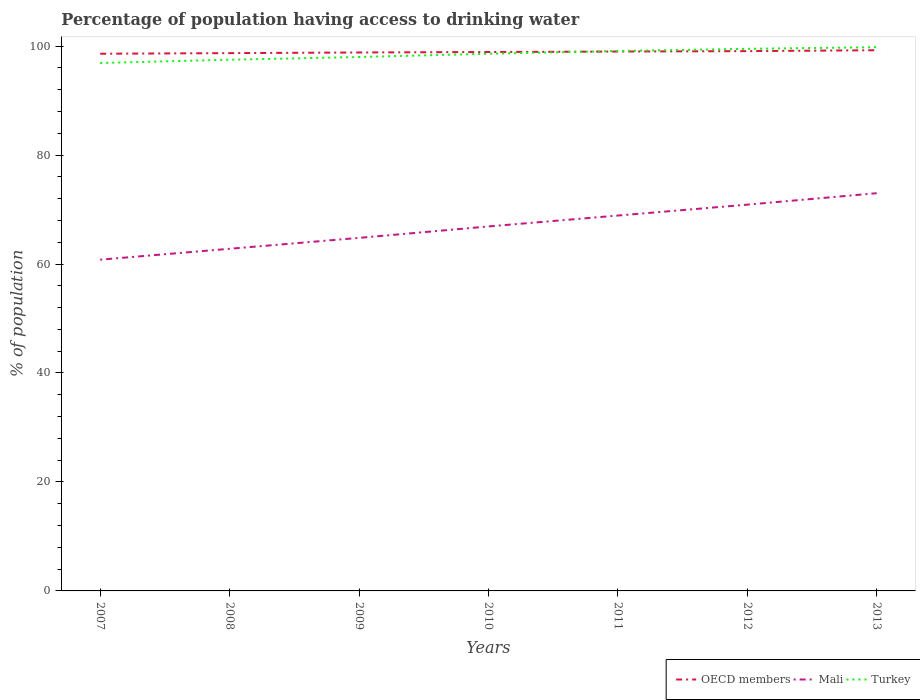How many different coloured lines are there?
Provide a succinct answer. 3. Does the line corresponding to OECD members intersect with the line corresponding to Turkey?
Give a very brief answer. Yes. Is the number of lines equal to the number of legend labels?
Your response must be concise. Yes. Across all years, what is the maximum percentage of population having access to drinking water in OECD members?
Ensure brevity in your answer.  98.6. In which year was the percentage of population having access to drinking water in OECD members maximum?
Ensure brevity in your answer.  2007. What is the total percentage of population having access to drinking water in Turkey in the graph?
Your answer should be very brief. -0.3. What is the difference between the highest and the second highest percentage of population having access to drinking water in Turkey?
Your answer should be very brief. 2.9. What is the difference between the highest and the lowest percentage of population having access to drinking water in Turkey?
Provide a succinct answer. 4. Is the percentage of population having access to drinking water in Turkey strictly greater than the percentage of population having access to drinking water in OECD members over the years?
Keep it short and to the point. No. How many lines are there?
Ensure brevity in your answer.  3. What is the difference between two consecutive major ticks on the Y-axis?
Your answer should be very brief. 20. Where does the legend appear in the graph?
Keep it short and to the point. Bottom right. What is the title of the graph?
Ensure brevity in your answer.  Percentage of population having access to drinking water. Does "Dominica" appear as one of the legend labels in the graph?
Offer a terse response. No. What is the label or title of the X-axis?
Provide a succinct answer. Years. What is the label or title of the Y-axis?
Offer a very short reply. % of population. What is the % of population of OECD members in 2007?
Make the answer very short. 98.6. What is the % of population of Mali in 2007?
Keep it short and to the point. 60.8. What is the % of population in Turkey in 2007?
Your response must be concise. 96.9. What is the % of population in OECD members in 2008?
Provide a succinct answer. 98.71. What is the % of population in Mali in 2008?
Keep it short and to the point. 62.8. What is the % of population in Turkey in 2008?
Ensure brevity in your answer.  97.5. What is the % of population of OECD members in 2009?
Provide a succinct answer. 98.83. What is the % of population of Mali in 2009?
Keep it short and to the point. 64.8. What is the % of population in OECD members in 2010?
Your answer should be compact. 98.92. What is the % of population of Mali in 2010?
Provide a short and direct response. 66.9. What is the % of population in Turkey in 2010?
Your answer should be compact. 98.6. What is the % of population of OECD members in 2011?
Provide a succinct answer. 99. What is the % of population in Mali in 2011?
Ensure brevity in your answer.  68.9. What is the % of population of Turkey in 2011?
Offer a very short reply. 99.1. What is the % of population in OECD members in 2012?
Give a very brief answer. 99.08. What is the % of population in Mali in 2012?
Provide a short and direct response. 70.9. What is the % of population of Turkey in 2012?
Give a very brief answer. 99.5. What is the % of population in OECD members in 2013?
Offer a very short reply. 99.24. What is the % of population in Turkey in 2013?
Your response must be concise. 99.8. Across all years, what is the maximum % of population in OECD members?
Ensure brevity in your answer.  99.24. Across all years, what is the maximum % of population of Mali?
Offer a very short reply. 73. Across all years, what is the maximum % of population of Turkey?
Keep it short and to the point. 99.8. Across all years, what is the minimum % of population of OECD members?
Your answer should be very brief. 98.6. Across all years, what is the minimum % of population of Mali?
Keep it short and to the point. 60.8. Across all years, what is the minimum % of population in Turkey?
Your response must be concise. 96.9. What is the total % of population in OECD members in the graph?
Give a very brief answer. 692.38. What is the total % of population of Mali in the graph?
Your response must be concise. 468.1. What is the total % of population in Turkey in the graph?
Offer a very short reply. 689.4. What is the difference between the % of population of OECD members in 2007 and that in 2008?
Your answer should be very brief. -0.11. What is the difference between the % of population of Mali in 2007 and that in 2008?
Give a very brief answer. -2. What is the difference between the % of population in Turkey in 2007 and that in 2008?
Your response must be concise. -0.6. What is the difference between the % of population in OECD members in 2007 and that in 2009?
Ensure brevity in your answer.  -0.23. What is the difference between the % of population in OECD members in 2007 and that in 2010?
Offer a terse response. -0.32. What is the difference between the % of population in Mali in 2007 and that in 2010?
Your answer should be very brief. -6.1. What is the difference between the % of population in OECD members in 2007 and that in 2011?
Offer a terse response. -0.4. What is the difference between the % of population of Mali in 2007 and that in 2011?
Offer a very short reply. -8.1. What is the difference between the % of population in OECD members in 2007 and that in 2012?
Keep it short and to the point. -0.48. What is the difference between the % of population in Mali in 2007 and that in 2012?
Offer a terse response. -10.1. What is the difference between the % of population of OECD members in 2007 and that in 2013?
Keep it short and to the point. -0.64. What is the difference between the % of population in Mali in 2007 and that in 2013?
Ensure brevity in your answer.  -12.2. What is the difference between the % of population of OECD members in 2008 and that in 2009?
Your response must be concise. -0.12. What is the difference between the % of population of Mali in 2008 and that in 2009?
Give a very brief answer. -2. What is the difference between the % of population in OECD members in 2008 and that in 2010?
Make the answer very short. -0.21. What is the difference between the % of population of Mali in 2008 and that in 2010?
Your response must be concise. -4.1. What is the difference between the % of population of Turkey in 2008 and that in 2010?
Your response must be concise. -1.1. What is the difference between the % of population in OECD members in 2008 and that in 2011?
Your answer should be very brief. -0.29. What is the difference between the % of population of Mali in 2008 and that in 2011?
Ensure brevity in your answer.  -6.1. What is the difference between the % of population in Turkey in 2008 and that in 2011?
Your answer should be very brief. -1.6. What is the difference between the % of population of OECD members in 2008 and that in 2012?
Provide a succinct answer. -0.37. What is the difference between the % of population in OECD members in 2008 and that in 2013?
Keep it short and to the point. -0.53. What is the difference between the % of population of Turkey in 2008 and that in 2013?
Your response must be concise. -2.3. What is the difference between the % of population of OECD members in 2009 and that in 2010?
Offer a terse response. -0.09. What is the difference between the % of population in Turkey in 2009 and that in 2010?
Your answer should be very brief. -0.6. What is the difference between the % of population in OECD members in 2009 and that in 2011?
Your answer should be compact. -0.17. What is the difference between the % of population of Mali in 2009 and that in 2011?
Your answer should be very brief. -4.1. What is the difference between the % of population of OECD members in 2009 and that in 2012?
Keep it short and to the point. -0.25. What is the difference between the % of population of Mali in 2009 and that in 2012?
Offer a very short reply. -6.1. What is the difference between the % of population in Turkey in 2009 and that in 2012?
Offer a terse response. -1.5. What is the difference between the % of population of OECD members in 2009 and that in 2013?
Provide a succinct answer. -0.41. What is the difference between the % of population of Turkey in 2009 and that in 2013?
Provide a short and direct response. -1.8. What is the difference between the % of population in OECD members in 2010 and that in 2011?
Offer a terse response. -0.08. What is the difference between the % of population of Mali in 2010 and that in 2011?
Ensure brevity in your answer.  -2. What is the difference between the % of population in OECD members in 2010 and that in 2012?
Offer a terse response. -0.16. What is the difference between the % of population of Mali in 2010 and that in 2012?
Provide a short and direct response. -4. What is the difference between the % of population in Turkey in 2010 and that in 2012?
Your answer should be very brief. -0.9. What is the difference between the % of population of OECD members in 2010 and that in 2013?
Make the answer very short. -0.33. What is the difference between the % of population in Mali in 2010 and that in 2013?
Keep it short and to the point. -6.1. What is the difference between the % of population of OECD members in 2011 and that in 2012?
Keep it short and to the point. -0.08. What is the difference between the % of population in Turkey in 2011 and that in 2012?
Offer a very short reply. -0.4. What is the difference between the % of population of OECD members in 2011 and that in 2013?
Your answer should be compact. -0.24. What is the difference between the % of population in OECD members in 2012 and that in 2013?
Ensure brevity in your answer.  -0.17. What is the difference between the % of population of Mali in 2012 and that in 2013?
Your answer should be compact. -2.1. What is the difference between the % of population of OECD members in 2007 and the % of population of Mali in 2008?
Your response must be concise. 35.8. What is the difference between the % of population in OECD members in 2007 and the % of population in Turkey in 2008?
Keep it short and to the point. 1.1. What is the difference between the % of population in Mali in 2007 and the % of population in Turkey in 2008?
Ensure brevity in your answer.  -36.7. What is the difference between the % of population of OECD members in 2007 and the % of population of Mali in 2009?
Your answer should be very brief. 33.8. What is the difference between the % of population in OECD members in 2007 and the % of population in Turkey in 2009?
Offer a terse response. 0.6. What is the difference between the % of population of Mali in 2007 and the % of population of Turkey in 2009?
Your response must be concise. -37.2. What is the difference between the % of population in OECD members in 2007 and the % of population in Mali in 2010?
Your response must be concise. 31.7. What is the difference between the % of population in OECD members in 2007 and the % of population in Turkey in 2010?
Give a very brief answer. 0. What is the difference between the % of population of Mali in 2007 and the % of population of Turkey in 2010?
Provide a succinct answer. -37.8. What is the difference between the % of population of OECD members in 2007 and the % of population of Mali in 2011?
Offer a terse response. 29.7. What is the difference between the % of population in OECD members in 2007 and the % of population in Turkey in 2011?
Ensure brevity in your answer.  -0.5. What is the difference between the % of population in Mali in 2007 and the % of population in Turkey in 2011?
Ensure brevity in your answer.  -38.3. What is the difference between the % of population in OECD members in 2007 and the % of population in Mali in 2012?
Give a very brief answer. 27.7. What is the difference between the % of population in OECD members in 2007 and the % of population in Turkey in 2012?
Keep it short and to the point. -0.9. What is the difference between the % of population in Mali in 2007 and the % of population in Turkey in 2012?
Keep it short and to the point. -38.7. What is the difference between the % of population of OECD members in 2007 and the % of population of Mali in 2013?
Offer a very short reply. 25.6. What is the difference between the % of population of OECD members in 2007 and the % of population of Turkey in 2013?
Make the answer very short. -1.2. What is the difference between the % of population in Mali in 2007 and the % of population in Turkey in 2013?
Ensure brevity in your answer.  -39. What is the difference between the % of population in OECD members in 2008 and the % of population in Mali in 2009?
Your answer should be very brief. 33.91. What is the difference between the % of population of OECD members in 2008 and the % of population of Turkey in 2009?
Provide a short and direct response. 0.71. What is the difference between the % of population of Mali in 2008 and the % of population of Turkey in 2009?
Offer a terse response. -35.2. What is the difference between the % of population of OECD members in 2008 and the % of population of Mali in 2010?
Ensure brevity in your answer.  31.81. What is the difference between the % of population of OECD members in 2008 and the % of population of Turkey in 2010?
Offer a very short reply. 0.11. What is the difference between the % of population in Mali in 2008 and the % of population in Turkey in 2010?
Offer a terse response. -35.8. What is the difference between the % of population of OECD members in 2008 and the % of population of Mali in 2011?
Provide a succinct answer. 29.81. What is the difference between the % of population of OECD members in 2008 and the % of population of Turkey in 2011?
Give a very brief answer. -0.39. What is the difference between the % of population of Mali in 2008 and the % of population of Turkey in 2011?
Provide a short and direct response. -36.3. What is the difference between the % of population of OECD members in 2008 and the % of population of Mali in 2012?
Ensure brevity in your answer.  27.81. What is the difference between the % of population in OECD members in 2008 and the % of population in Turkey in 2012?
Your answer should be compact. -0.79. What is the difference between the % of population in Mali in 2008 and the % of population in Turkey in 2012?
Offer a very short reply. -36.7. What is the difference between the % of population of OECD members in 2008 and the % of population of Mali in 2013?
Keep it short and to the point. 25.71. What is the difference between the % of population of OECD members in 2008 and the % of population of Turkey in 2013?
Your answer should be very brief. -1.09. What is the difference between the % of population of Mali in 2008 and the % of population of Turkey in 2013?
Provide a succinct answer. -37. What is the difference between the % of population of OECD members in 2009 and the % of population of Mali in 2010?
Offer a very short reply. 31.93. What is the difference between the % of population in OECD members in 2009 and the % of population in Turkey in 2010?
Offer a terse response. 0.23. What is the difference between the % of population of Mali in 2009 and the % of population of Turkey in 2010?
Ensure brevity in your answer.  -33.8. What is the difference between the % of population of OECD members in 2009 and the % of population of Mali in 2011?
Ensure brevity in your answer.  29.93. What is the difference between the % of population in OECD members in 2009 and the % of population in Turkey in 2011?
Make the answer very short. -0.27. What is the difference between the % of population of Mali in 2009 and the % of population of Turkey in 2011?
Make the answer very short. -34.3. What is the difference between the % of population in OECD members in 2009 and the % of population in Mali in 2012?
Offer a terse response. 27.93. What is the difference between the % of population of OECD members in 2009 and the % of population of Turkey in 2012?
Provide a succinct answer. -0.67. What is the difference between the % of population of Mali in 2009 and the % of population of Turkey in 2012?
Your answer should be very brief. -34.7. What is the difference between the % of population in OECD members in 2009 and the % of population in Mali in 2013?
Keep it short and to the point. 25.83. What is the difference between the % of population of OECD members in 2009 and the % of population of Turkey in 2013?
Provide a short and direct response. -0.97. What is the difference between the % of population in Mali in 2009 and the % of population in Turkey in 2013?
Offer a terse response. -35. What is the difference between the % of population in OECD members in 2010 and the % of population in Mali in 2011?
Your response must be concise. 30.02. What is the difference between the % of population in OECD members in 2010 and the % of population in Turkey in 2011?
Keep it short and to the point. -0.18. What is the difference between the % of population of Mali in 2010 and the % of population of Turkey in 2011?
Keep it short and to the point. -32.2. What is the difference between the % of population of OECD members in 2010 and the % of population of Mali in 2012?
Make the answer very short. 28.02. What is the difference between the % of population of OECD members in 2010 and the % of population of Turkey in 2012?
Your response must be concise. -0.58. What is the difference between the % of population in Mali in 2010 and the % of population in Turkey in 2012?
Offer a very short reply. -32.6. What is the difference between the % of population of OECD members in 2010 and the % of population of Mali in 2013?
Ensure brevity in your answer.  25.92. What is the difference between the % of population in OECD members in 2010 and the % of population in Turkey in 2013?
Give a very brief answer. -0.88. What is the difference between the % of population of Mali in 2010 and the % of population of Turkey in 2013?
Offer a very short reply. -32.9. What is the difference between the % of population of OECD members in 2011 and the % of population of Mali in 2012?
Offer a terse response. 28.1. What is the difference between the % of population of OECD members in 2011 and the % of population of Turkey in 2012?
Keep it short and to the point. -0.5. What is the difference between the % of population of Mali in 2011 and the % of population of Turkey in 2012?
Offer a very short reply. -30.6. What is the difference between the % of population in OECD members in 2011 and the % of population in Mali in 2013?
Your answer should be very brief. 26. What is the difference between the % of population in OECD members in 2011 and the % of population in Turkey in 2013?
Provide a succinct answer. -0.8. What is the difference between the % of population of Mali in 2011 and the % of population of Turkey in 2013?
Provide a succinct answer. -30.9. What is the difference between the % of population in OECD members in 2012 and the % of population in Mali in 2013?
Provide a short and direct response. 26.08. What is the difference between the % of population in OECD members in 2012 and the % of population in Turkey in 2013?
Ensure brevity in your answer.  -0.72. What is the difference between the % of population in Mali in 2012 and the % of population in Turkey in 2013?
Provide a succinct answer. -28.9. What is the average % of population of OECD members per year?
Give a very brief answer. 98.91. What is the average % of population of Mali per year?
Offer a terse response. 66.87. What is the average % of population of Turkey per year?
Ensure brevity in your answer.  98.49. In the year 2007, what is the difference between the % of population of OECD members and % of population of Mali?
Give a very brief answer. 37.8. In the year 2007, what is the difference between the % of population of OECD members and % of population of Turkey?
Give a very brief answer. 1.7. In the year 2007, what is the difference between the % of population in Mali and % of population in Turkey?
Keep it short and to the point. -36.1. In the year 2008, what is the difference between the % of population of OECD members and % of population of Mali?
Provide a succinct answer. 35.91. In the year 2008, what is the difference between the % of population of OECD members and % of population of Turkey?
Offer a very short reply. 1.21. In the year 2008, what is the difference between the % of population of Mali and % of population of Turkey?
Offer a very short reply. -34.7. In the year 2009, what is the difference between the % of population in OECD members and % of population in Mali?
Keep it short and to the point. 34.03. In the year 2009, what is the difference between the % of population of OECD members and % of population of Turkey?
Offer a very short reply. 0.83. In the year 2009, what is the difference between the % of population in Mali and % of population in Turkey?
Provide a succinct answer. -33.2. In the year 2010, what is the difference between the % of population of OECD members and % of population of Mali?
Provide a succinct answer. 32.02. In the year 2010, what is the difference between the % of population in OECD members and % of population in Turkey?
Make the answer very short. 0.32. In the year 2010, what is the difference between the % of population of Mali and % of population of Turkey?
Your answer should be compact. -31.7. In the year 2011, what is the difference between the % of population of OECD members and % of population of Mali?
Offer a terse response. 30.1. In the year 2011, what is the difference between the % of population in OECD members and % of population in Turkey?
Provide a short and direct response. -0.1. In the year 2011, what is the difference between the % of population in Mali and % of population in Turkey?
Provide a succinct answer. -30.2. In the year 2012, what is the difference between the % of population in OECD members and % of population in Mali?
Make the answer very short. 28.18. In the year 2012, what is the difference between the % of population of OECD members and % of population of Turkey?
Ensure brevity in your answer.  -0.42. In the year 2012, what is the difference between the % of population of Mali and % of population of Turkey?
Give a very brief answer. -28.6. In the year 2013, what is the difference between the % of population of OECD members and % of population of Mali?
Make the answer very short. 26.24. In the year 2013, what is the difference between the % of population of OECD members and % of population of Turkey?
Ensure brevity in your answer.  -0.56. In the year 2013, what is the difference between the % of population in Mali and % of population in Turkey?
Your response must be concise. -26.8. What is the ratio of the % of population of OECD members in 2007 to that in 2008?
Offer a terse response. 1. What is the ratio of the % of population of Mali in 2007 to that in 2008?
Provide a succinct answer. 0.97. What is the ratio of the % of population in Mali in 2007 to that in 2009?
Provide a short and direct response. 0.94. What is the ratio of the % of population of Turkey in 2007 to that in 2009?
Keep it short and to the point. 0.99. What is the ratio of the % of population in OECD members in 2007 to that in 2010?
Your answer should be compact. 1. What is the ratio of the % of population of Mali in 2007 to that in 2010?
Ensure brevity in your answer.  0.91. What is the ratio of the % of population of Turkey in 2007 to that in 2010?
Give a very brief answer. 0.98. What is the ratio of the % of population of Mali in 2007 to that in 2011?
Your response must be concise. 0.88. What is the ratio of the % of population in Turkey in 2007 to that in 2011?
Keep it short and to the point. 0.98. What is the ratio of the % of population in OECD members in 2007 to that in 2012?
Offer a very short reply. 1. What is the ratio of the % of population in Mali in 2007 to that in 2012?
Offer a terse response. 0.86. What is the ratio of the % of population in Turkey in 2007 to that in 2012?
Your response must be concise. 0.97. What is the ratio of the % of population in OECD members in 2007 to that in 2013?
Offer a very short reply. 0.99. What is the ratio of the % of population of Mali in 2007 to that in 2013?
Make the answer very short. 0.83. What is the ratio of the % of population of Turkey in 2007 to that in 2013?
Provide a short and direct response. 0.97. What is the ratio of the % of population of OECD members in 2008 to that in 2009?
Provide a succinct answer. 1. What is the ratio of the % of population of Mali in 2008 to that in 2009?
Provide a succinct answer. 0.97. What is the ratio of the % of population in Turkey in 2008 to that in 2009?
Keep it short and to the point. 0.99. What is the ratio of the % of population in OECD members in 2008 to that in 2010?
Give a very brief answer. 1. What is the ratio of the % of population of Mali in 2008 to that in 2010?
Your response must be concise. 0.94. What is the ratio of the % of population of Turkey in 2008 to that in 2010?
Provide a short and direct response. 0.99. What is the ratio of the % of population of OECD members in 2008 to that in 2011?
Provide a succinct answer. 1. What is the ratio of the % of population in Mali in 2008 to that in 2011?
Your answer should be very brief. 0.91. What is the ratio of the % of population of Turkey in 2008 to that in 2011?
Make the answer very short. 0.98. What is the ratio of the % of population in Mali in 2008 to that in 2012?
Keep it short and to the point. 0.89. What is the ratio of the % of population of Turkey in 2008 to that in 2012?
Ensure brevity in your answer.  0.98. What is the ratio of the % of population of OECD members in 2008 to that in 2013?
Your response must be concise. 0.99. What is the ratio of the % of population in Mali in 2008 to that in 2013?
Your response must be concise. 0.86. What is the ratio of the % of population of Mali in 2009 to that in 2010?
Make the answer very short. 0.97. What is the ratio of the % of population in OECD members in 2009 to that in 2011?
Ensure brevity in your answer.  1. What is the ratio of the % of population of Mali in 2009 to that in 2011?
Offer a very short reply. 0.94. What is the ratio of the % of population in Turkey in 2009 to that in 2011?
Provide a succinct answer. 0.99. What is the ratio of the % of population of Mali in 2009 to that in 2012?
Keep it short and to the point. 0.91. What is the ratio of the % of population in Turkey in 2009 to that in 2012?
Provide a succinct answer. 0.98. What is the ratio of the % of population in Mali in 2009 to that in 2013?
Offer a very short reply. 0.89. What is the ratio of the % of population in Turkey in 2009 to that in 2013?
Provide a short and direct response. 0.98. What is the ratio of the % of population in OECD members in 2010 to that in 2012?
Your response must be concise. 1. What is the ratio of the % of population in Mali in 2010 to that in 2012?
Your response must be concise. 0.94. What is the ratio of the % of population in Mali in 2010 to that in 2013?
Offer a very short reply. 0.92. What is the ratio of the % of population of Turkey in 2010 to that in 2013?
Offer a terse response. 0.99. What is the ratio of the % of population in Mali in 2011 to that in 2012?
Make the answer very short. 0.97. What is the ratio of the % of population in Turkey in 2011 to that in 2012?
Your answer should be very brief. 1. What is the ratio of the % of population in OECD members in 2011 to that in 2013?
Keep it short and to the point. 1. What is the ratio of the % of population in Mali in 2011 to that in 2013?
Provide a succinct answer. 0.94. What is the ratio of the % of population of OECD members in 2012 to that in 2013?
Give a very brief answer. 1. What is the ratio of the % of population of Mali in 2012 to that in 2013?
Your answer should be very brief. 0.97. What is the ratio of the % of population in Turkey in 2012 to that in 2013?
Offer a terse response. 1. What is the difference between the highest and the second highest % of population of OECD members?
Make the answer very short. 0.17. What is the difference between the highest and the lowest % of population of OECD members?
Offer a very short reply. 0.64. What is the difference between the highest and the lowest % of population in Turkey?
Offer a very short reply. 2.9. 